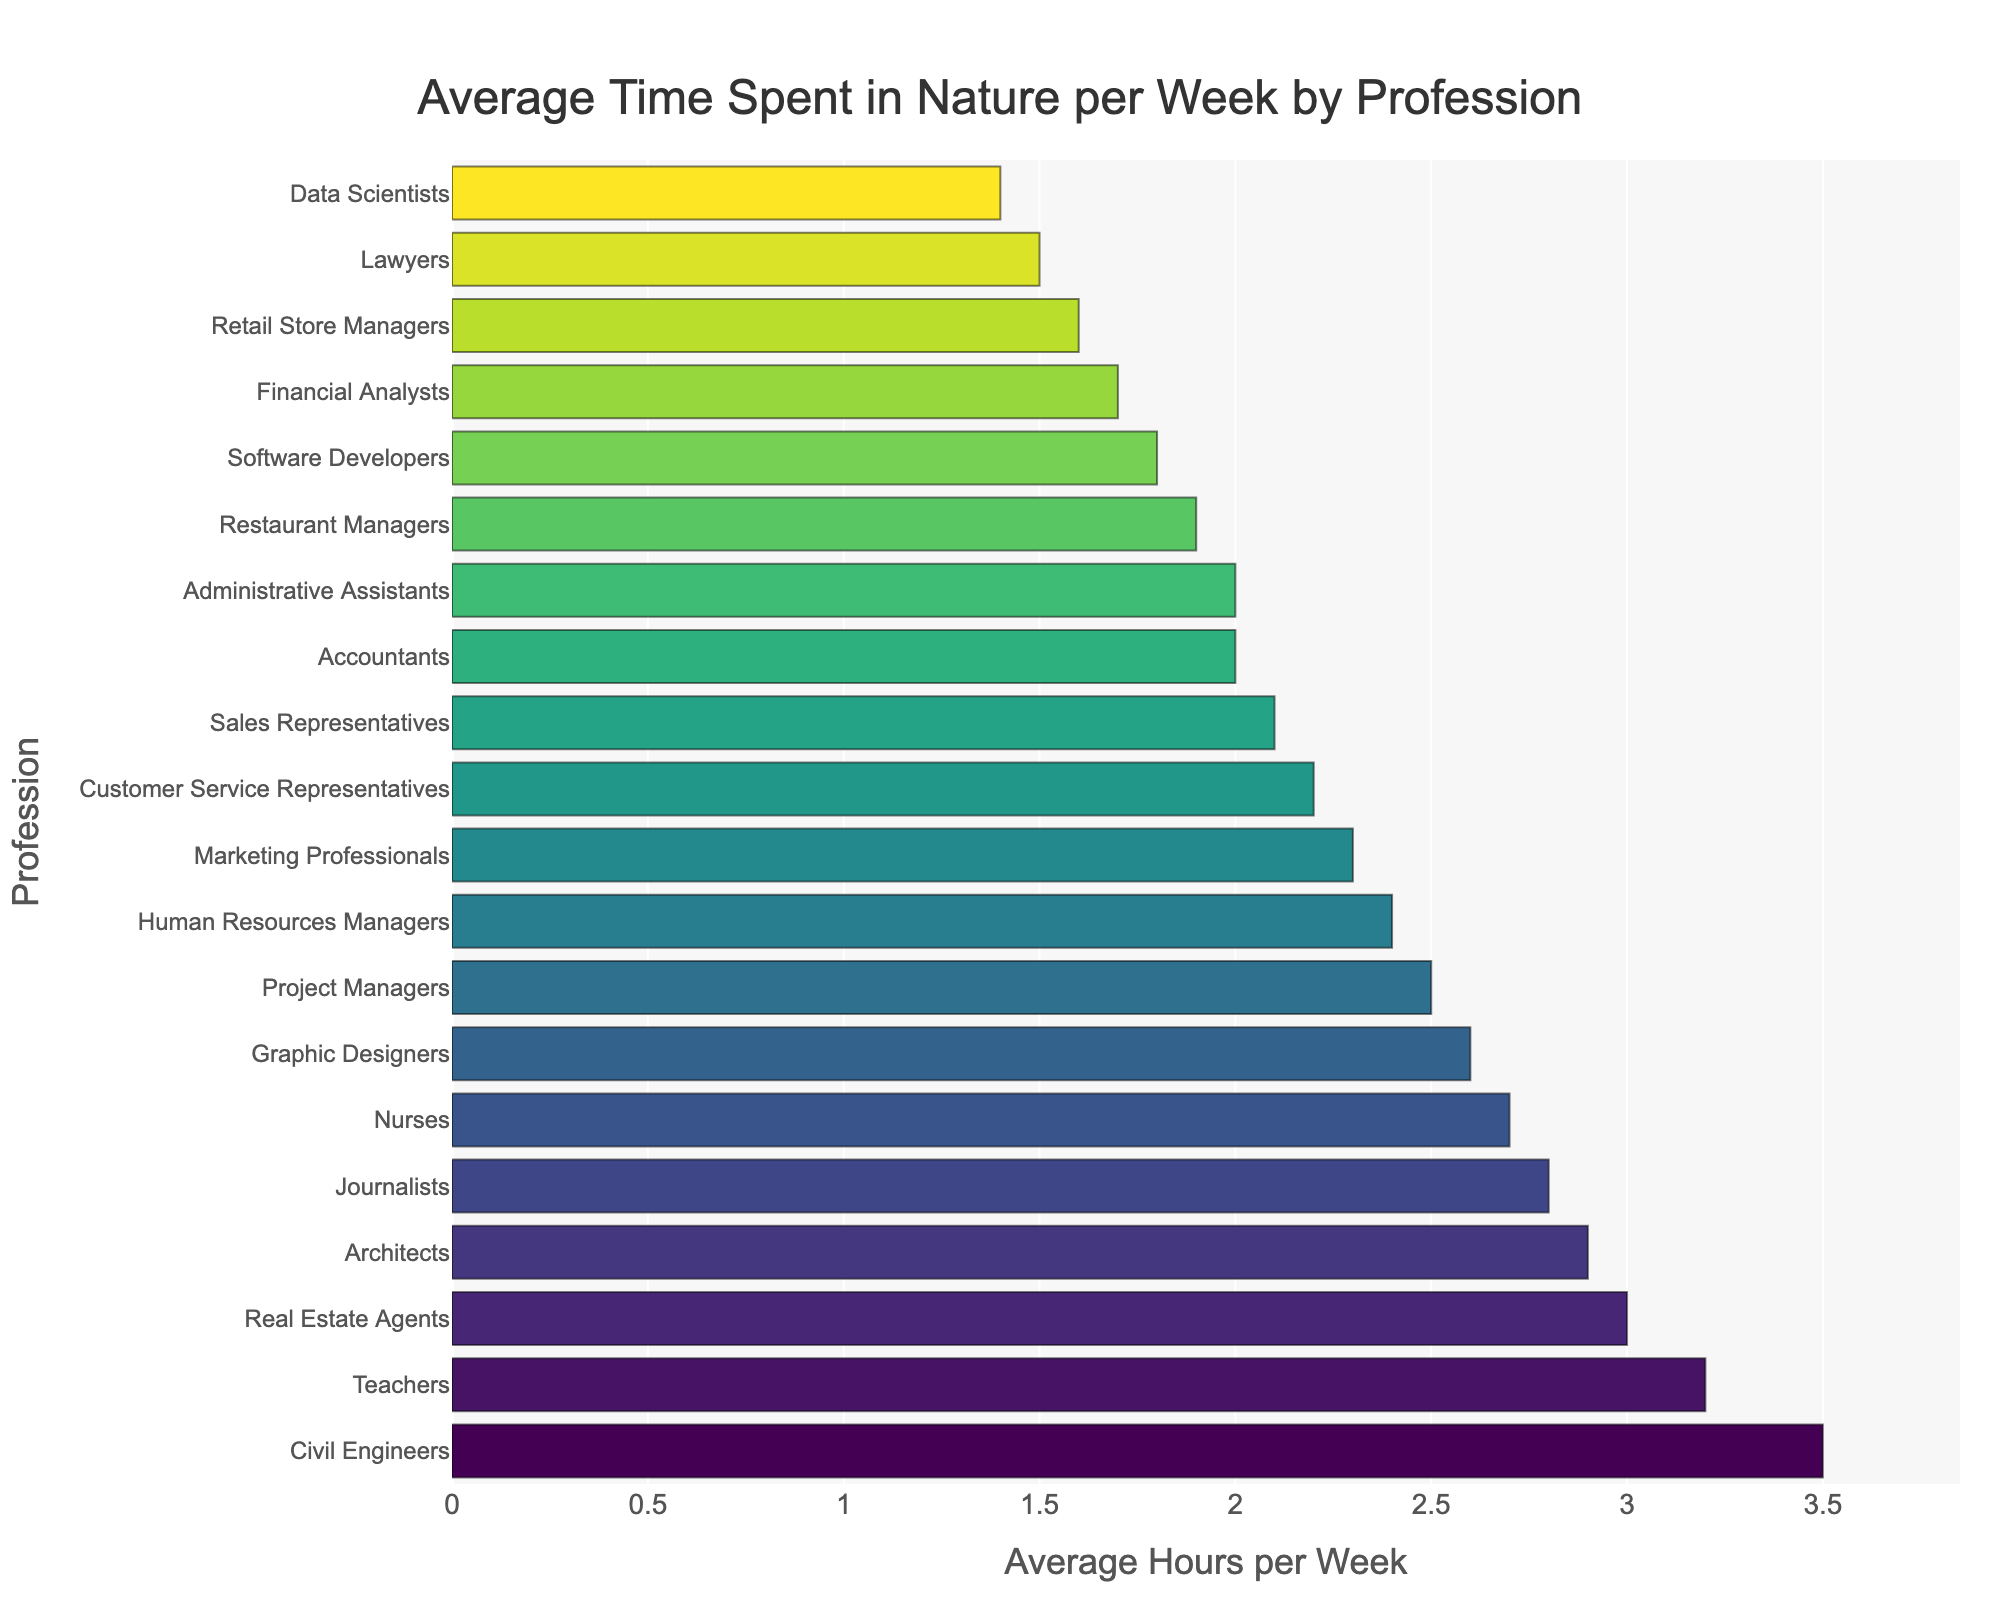Which profession spends the most average hours in nature per week? Identify the bar with the greatest length and the highest position on the y-axis. Here, Civil Engineers spend the most average hours in nature per week.
Answer: Civil Engineers Which profession spends the least average hours in nature per week? Identify the bar with the shortest length and the lowest position on the y-axis. Here, Data Scientists spend the least average hours in nature per week.
Answer: Data Scientists How much more time do Teachers spend in nature compared to Software Developers per week? Locate the bars for Teachers and Software Developers. Subtract the number of hours for Software Developers from the number of hours for Teachers: 3.2 - 1.8 = 1.4 hours.
Answer: 1.4 hours What is the average number of hours spent in nature by Project Managers, Marketing Professionals, and Architects? Add the average hours for each profession and divide by the number of professions: (2.5 + 2.3 + 2.9) / 3 = 2.5667. Round to 2.57 hours.
Answer: 2.57 hours Do Nurses or Human Resources Managers spend more time in nature per week? Compare the lengths of the bars for Nurses and Human Resources Managers. Nurses spend 2.7 hours, and Human Resources Managers spend 2.4 hours. Nurses spend more time.
Answer: Nurses What is the combined average time spent in nature per week by Real Estate Agents and Journalists? Sum the average hours for both professions: 3.0 + 2.8 = 5.8 hours.
Answer: 5.8 hours Which profession spends approximately twice the average time in nature per week as Lawyers? Look for a bar that represents approximately twice the average hours of Lawyers (1.5 * 2 = 3.0 hours). Real Estate Agents (3.0 hours) fit this description.
Answer: Real Estate Agents What is the difference in average time spent in nature per week between the highest and lowest professions? Locate the bars for Civil Engineers (3.5 hours) and Data Scientists (1.4 hours). Subtract the lowest value from the highest: 3.5 - 1.4 = 2.1 hours.
Answer: 2.1 hours 